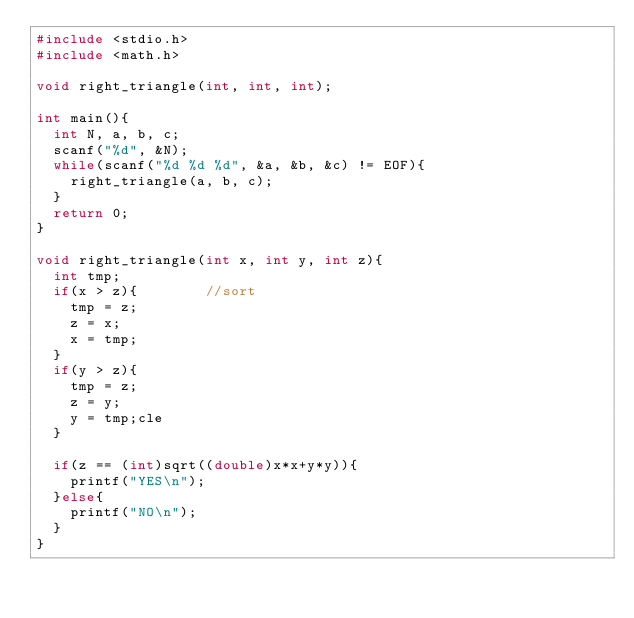Convert code to text. <code><loc_0><loc_0><loc_500><loc_500><_C_>#include <stdio.h>
#include <math.h>

void right_triangle(int, int, int);

int main(){
	int N, a, b, c;
	scanf("%d", &N);
	while(scanf("%d %d %d", &a, &b, &c) != EOF){
		right_triangle(a, b, c);
	}
	return 0;
}

void right_triangle(int x, int y, int z){
	int tmp;
	if(x > z){				//sort
		tmp = z;
		z = x;
		x = tmp;
	}
	if(y > z){
		tmp = z;
		z = y;
		y = tmp;cle
	}

	if(z == (int)sqrt((double)x*x+y*y)){			
		printf("YES\n");
	}else{
		printf("NO\n");
	}
}</code> 